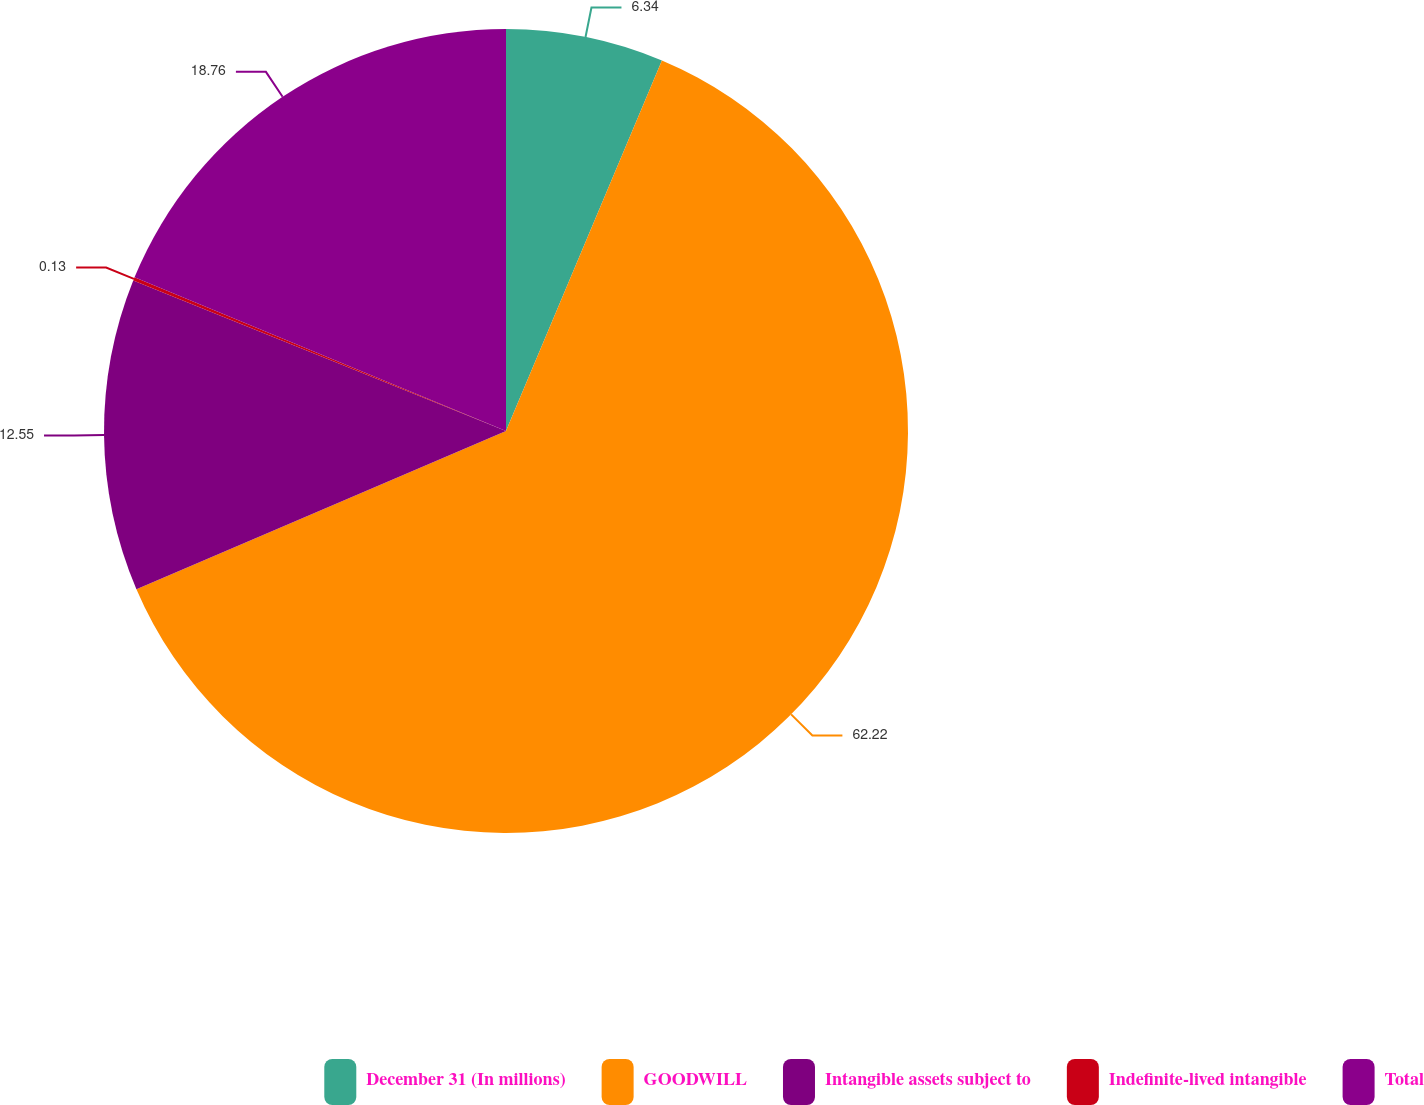Convert chart. <chart><loc_0><loc_0><loc_500><loc_500><pie_chart><fcel>December 31 (In millions)<fcel>GOODWILL<fcel>Intangible assets subject to<fcel>Indefinite-lived intangible<fcel>Total<nl><fcel>6.34%<fcel>62.23%<fcel>12.55%<fcel>0.13%<fcel>18.76%<nl></chart> 